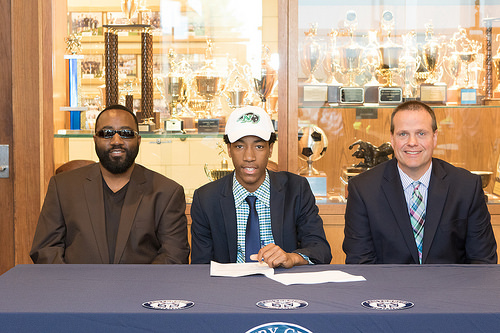<image>
Can you confirm if the soccer ball is behind the man? Yes. From this viewpoint, the soccer ball is positioned behind the man, with the man partially or fully occluding the soccer ball. Is the soccer ball to the right of the white hat? Yes. From this viewpoint, the soccer ball is positioned to the right side relative to the white hat. 